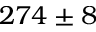Convert formula to latex. <formula><loc_0><loc_0><loc_500><loc_500>2 7 4 \pm 8</formula> 